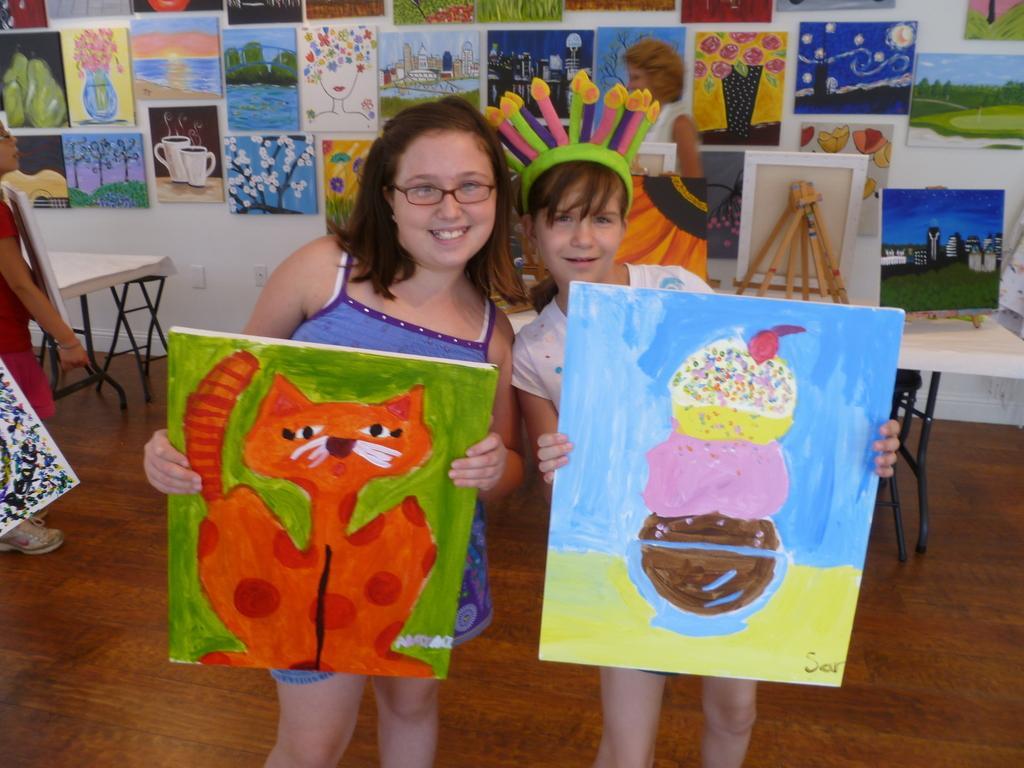Can you describe this image briefly? In the picture there are two kids holding paintings,Of which one is cat and other is ice cream. On the background wall there are many paintings on it. 